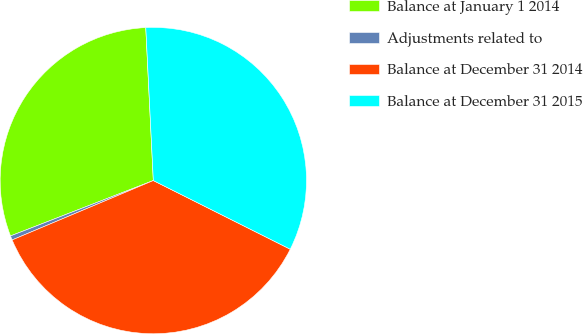<chart> <loc_0><loc_0><loc_500><loc_500><pie_chart><fcel>Balance at January 1 2014<fcel>Adjustments related to<fcel>Balance at December 31 2014<fcel>Balance at December 31 2015<nl><fcel>30.1%<fcel>0.45%<fcel>36.26%<fcel>33.18%<nl></chart> 